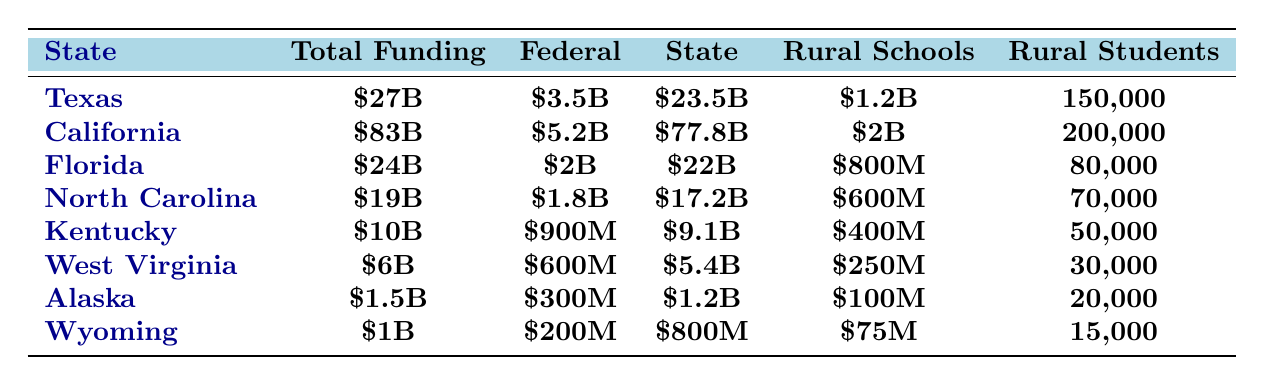What state has the highest total funding for education? Looking at the “Total Funding” column, California has the highest total funding at $83 billion.
Answer: California How much federal funding does Texas receive? The table shows that Texas receives $3.5 billion in federal funding.
Answer: $3.5 billion What is the total amount of funding for rural schools in Florida? According to the table, Florida allocates $800 million for rural schools.
Answer: $800 million Which state has the lowest funding for rural schools? From the “Rural Schools” column, Wyoming has the lowest funding at $75 million.
Answer: Wyoming How many rural students are supported in North Carolina? The table indicates that North Carolina supports 70,000 rural students.
Answer: 70,000 What is the difference in rural schools funding between California and Texas? California's funding for rural schools is $2 billion, while Texas' is $1.2 billion. The difference is $2 billion - $1.2 billion = $800 million.
Answer: $800 million What percentage of total funding in Alaska is allocated to rural schools? In Alaska, the total funding is $1.5 billion and the rural schools funding is $100 million. The percentage is calculated as ($100 million / $1.5 billion) * 100 = 6.67%.
Answer: 6.67% If you sum the total funding for rural schools across all states, what is the total? The total funding for rural schools is calculated as $1.2 billion (Texas) + $2 billion (California) + $800 million (Florida) + $600 million (North Carolina) + $400 million (Kentucky) + $250 million (West Virginia) + $100 million (Alaska) + $75 million (Wyoming) = $5.425 billion.
Answer: $5.425 billion Is the federal contribution to education in Kentucky greater than that in West Virginia? The federal contribution in Kentucky is $900 million and in West Virginia is $600 million. Therefore, $900 million > $600 million is true.
Answer: Yes Which state supports the most rural students and how many? California supports the most rural students, with a total of 200,000.
Answer: California, 200,000 How much more does California contribute to education from state funding compared to North Carolina? California's state contribution is $77.8 billion, while North Carolina's is $17.2 billion. The difference is $77.8 billion - $17.2 billion = $60.6 billion.
Answer: $60.6 billion 